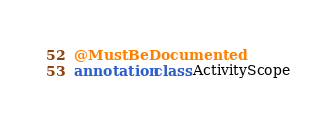<code> <loc_0><loc_0><loc_500><loc_500><_Kotlin_>@MustBeDocumented
annotation class ActivityScope</code> 